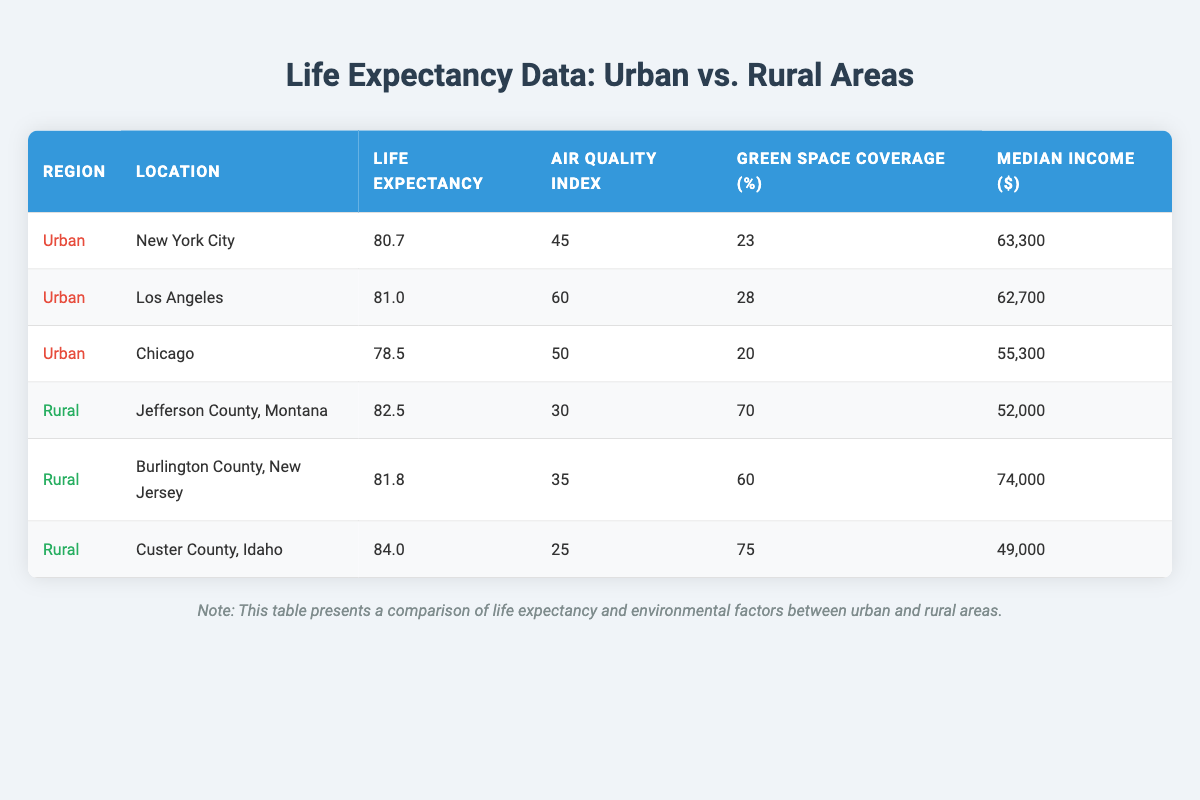What is the average life expectancy in urban areas? To find the average life expectancy in urban areas, we take the average from the three urban cities: New York City (80.7), Los Angeles (81.0), and Chicago (78.5). The sum is (80.7 + 81.0 + 78.5) = 240.2. Dividing by 3 gives us an average of 240.2 / 3 = 80.07.
Answer: 80.07 What is the air quality index of Custer County, Idaho? Looking at the row for Custer County, Idaho, we can see that the air quality index listed is 25.
Answer: 25 Does any urban city have a higher average life expectancy than all rural counties combined? The average life expectancy for rural counties must be calculated first. The average for Jefferson County (82.5), Burlington County (81.8), and Custer County (84.0) is (82.5 + 81.8 + 84.0) = 248.3, then divided by 3 gives an average of 82.77. The highest urban life expectancy is Los Angeles (81.0), which is less than 82.77.
Answer: No Which region has the highest median income and what is that amount? The table shows the median incomes for each area: New York City (63300), Los Angeles (62700), Chicago (55300), Jefferson County (52000), Burlington County (74000), and Custer County (49000). The highest median income is Burlington County at 74000.
Answer: 74000 What is the average green space coverage in rural areas? The green space coverage for rural counties is: Jefferson County (70), Burlington County (60), and Custer County (75). The sum is (70 + 60 + 75) = 205. Dividing this sum by the 3 rural counties gives an average of 205 / 3 = 68.33.
Answer: 68.33 Which urban area has the highest air quality index? Looking at the urban cities, their air quality indices are: New York City (45), Los Angeles (60), and Chicago (50). The highest of these is Los Angeles at 60.
Answer: Los Angeles Is it true that all urban areas have air quality indices above 40? There are three urban areas listed: New York City (45), Los Angeles (60), and Chicago (50). All these values are above 40, so the statement is true.
Answer: Yes What is the difference in average life expectancy between the highest and lowest urban areas? The highest life expectancy in urban areas is found in Los Angeles at 81.0, while the lowest is in Chicago at 78.5. The difference is 81.0 - 78.5 = 2.5.
Answer: 2.5 